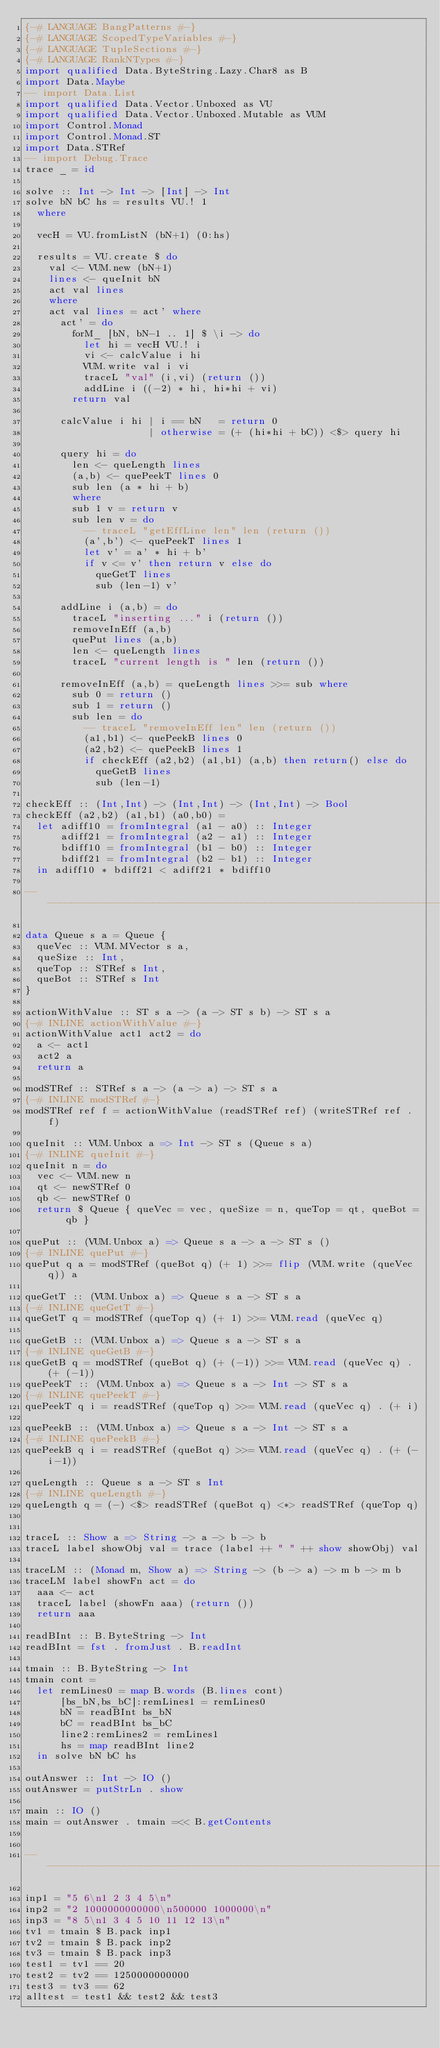<code> <loc_0><loc_0><loc_500><loc_500><_Haskell_>{-# LANGUAGE BangPatterns #-}
{-# LANGUAGE ScopedTypeVariables #-}
{-# LANGUAGE TupleSections #-}
{-# LANGUAGE RankNTypes #-}
import qualified Data.ByteString.Lazy.Char8 as B
import Data.Maybe
-- import Data.List
import qualified Data.Vector.Unboxed as VU
import qualified Data.Vector.Unboxed.Mutable as VUM
import Control.Monad
import Control.Monad.ST
import Data.STRef
-- import Debug.Trace
trace _ = id

solve :: Int -> Int -> [Int] -> Int
solve bN bC hs = results VU.! 1
  where

  vecH = VU.fromListN (bN+1) (0:hs)

  results = VU.create $ do
    val <- VUM.new (bN+1)
    lines <- queInit bN
    act val lines
    where
    act val lines = act' where
      act' = do
        forM_ [bN, bN-1 .. 1] $ \i -> do
          let hi = vecH VU.! i
          vi <- calcValue i hi
          VUM.write val i vi
          traceL "val" (i,vi) (return ())
          addLine i ((-2) * hi, hi*hi + vi)
        return val

      calcValue i hi | i == bN   = return 0
                     | otherwise = (+ (hi*hi + bC)) <$> query hi
        
      query hi = do
        len <- queLength lines
        (a,b) <- quePeekT lines 0
        sub len (a * hi + b)
        where
        sub 1 v = return v
        sub len v = do
          -- traceL "getEffLine len" len (return ())
          (a',b') <- quePeekT lines 1
          let v' = a' * hi + b'
          if v <= v' then return v else do
            queGetT lines
            sub (len-1) v'
            
      addLine i (a,b) = do
        traceL "inserting ..." i (return ())
        removeInEff (a,b)
        quePut lines (a,b)
        len <- queLength lines
        traceL "current length is " len (return ())

      removeInEff (a,b) = queLength lines >>= sub where
        sub 0 = return ()
        sub 1 = return ()
        sub len = do
          -- traceL "removeInEff len" len (return ())
          (a1,b1) <- quePeekB lines 0
          (a2,b2) <- quePeekB lines 1
          if checkEff (a2,b2) (a1,b1) (a,b) then return() else do
            queGetB lines
            sub (len-1)
        
checkEff :: (Int,Int) -> (Int,Int) -> (Int,Int) -> Bool
checkEff (a2,b2) (a1,b1) (a0,b0) =
  let adiff10 = fromIntegral (a1 - a0) :: Integer
      adiff21 = fromIntegral (a2 - a1) :: Integer
      bdiff10 = fromIntegral (b1 - b0) :: Integer
      bdiff21 = fromIntegral (b2 - b1) :: Integer
  in adiff10 * bdiff21 < adiff21 * bdiff10

----------------------------------------------------------------------

data Queue s a = Queue {
  queVec :: VUM.MVector s a,
  queSize :: Int,
  queTop :: STRef s Int,
  queBot :: STRef s Int
}

actionWithValue :: ST s a -> (a -> ST s b) -> ST s a
{-# INLINE actionWithValue #-}
actionWithValue act1 act2 = do
  a <- act1
  act2 a
  return a

modSTRef :: STRef s a -> (a -> a) -> ST s a
{-# INLINE modSTRef #-}
modSTRef ref f = actionWithValue (readSTRef ref) (writeSTRef ref . f)

queInit :: VUM.Unbox a => Int -> ST s (Queue s a)
{-# INLINE queInit #-}
queInit n = do
  vec <- VUM.new n
  qt <- newSTRef 0
  qb <- newSTRef 0
  return $ Queue { queVec = vec, queSize = n, queTop = qt, queBot = qb }

quePut :: (VUM.Unbox a) => Queue s a -> a -> ST s ()
{-# INLINE quePut #-}
quePut q a = modSTRef (queBot q) (+ 1) >>= flip (VUM.write (queVec q)) a

queGetT :: (VUM.Unbox a) => Queue s a -> ST s a
{-# INLINE queGetT #-}
queGetT q = modSTRef (queTop q) (+ 1) >>= VUM.read (queVec q)

queGetB :: (VUM.Unbox a) => Queue s a -> ST s a
{-# INLINE queGetB #-}
queGetB q = modSTRef (queBot q) (+ (-1)) >>= VUM.read (queVec q) . (+ (-1))
quePeekT :: (VUM.Unbox a) => Queue s a -> Int -> ST s a
{-# INLINE quePeekT #-}
quePeekT q i = readSTRef (queTop q) >>= VUM.read (queVec q) . (+ i)

quePeekB :: (VUM.Unbox a) => Queue s a -> Int -> ST s a
{-# INLINE quePeekB #-}
quePeekB q i = readSTRef (queBot q) >>= VUM.read (queVec q) . (+ (-i-1))

queLength :: Queue s a -> ST s Int
{-# INLINE queLength #-}
queLength q = (-) <$> readSTRef (queBot q) <*> readSTRef (queTop q)
  

traceL :: Show a => String -> a -> b -> b
traceL label showObj val = trace (label ++ " " ++ show showObj) val

traceLM :: (Monad m, Show a) => String -> (b -> a) -> m b -> m b
traceLM label showFn act = do
  aaa <- act
  traceL label (showFn aaa) (return ())
  return aaa

readBInt :: B.ByteString -> Int
readBInt = fst . fromJust . B.readInt

tmain :: B.ByteString -> Int
tmain cont =
  let remLines0 = map B.words (B.lines cont)
      [bs_bN,bs_bC]:remLines1 = remLines0
      bN = readBInt bs_bN
      bC = readBInt bs_bC
      line2:remLines2 = remLines1
      hs = map readBInt line2
  in solve bN bC hs

outAnswer :: Int -> IO ()
outAnswer = putStrLn . show

main :: IO ()
main = outAnswer . tmain =<< B.getContents


-------------------------------------------------------------------------------

inp1 = "5 6\n1 2 3 4 5\n"
inp2 = "2 1000000000000\n500000 1000000\n"
inp3 = "8 5\n1 3 4 5 10 11 12 13\n"
tv1 = tmain $ B.pack inp1
tv2 = tmain $ B.pack inp2
tv3 = tmain $ B.pack inp3
test1 = tv1 == 20
test2 = tv2 == 1250000000000
test3 = tv3 == 62
alltest = test1 && test2 && test3

</code> 